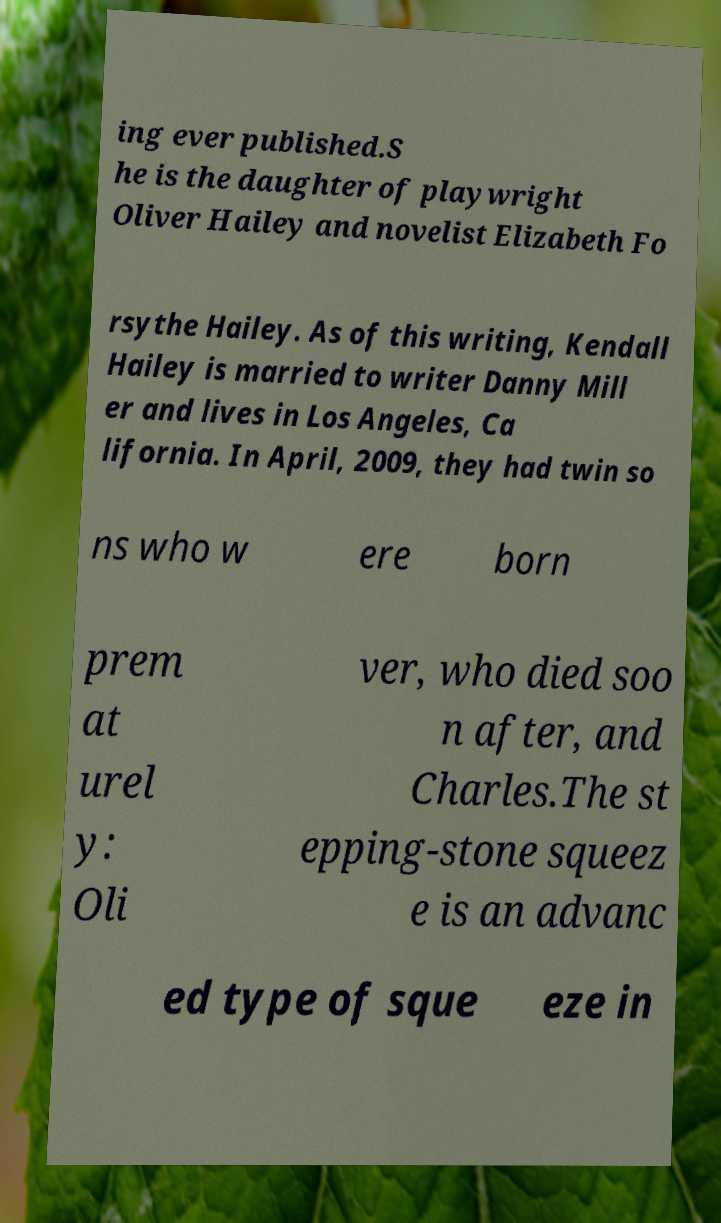There's text embedded in this image that I need extracted. Can you transcribe it verbatim? ing ever published.S he is the daughter of playwright Oliver Hailey and novelist Elizabeth Fo rsythe Hailey. As of this writing, Kendall Hailey is married to writer Danny Mill er and lives in Los Angeles, Ca lifornia. In April, 2009, they had twin so ns who w ere born prem at urel y: Oli ver, who died soo n after, and Charles.The st epping-stone squeez e is an advanc ed type of sque eze in 